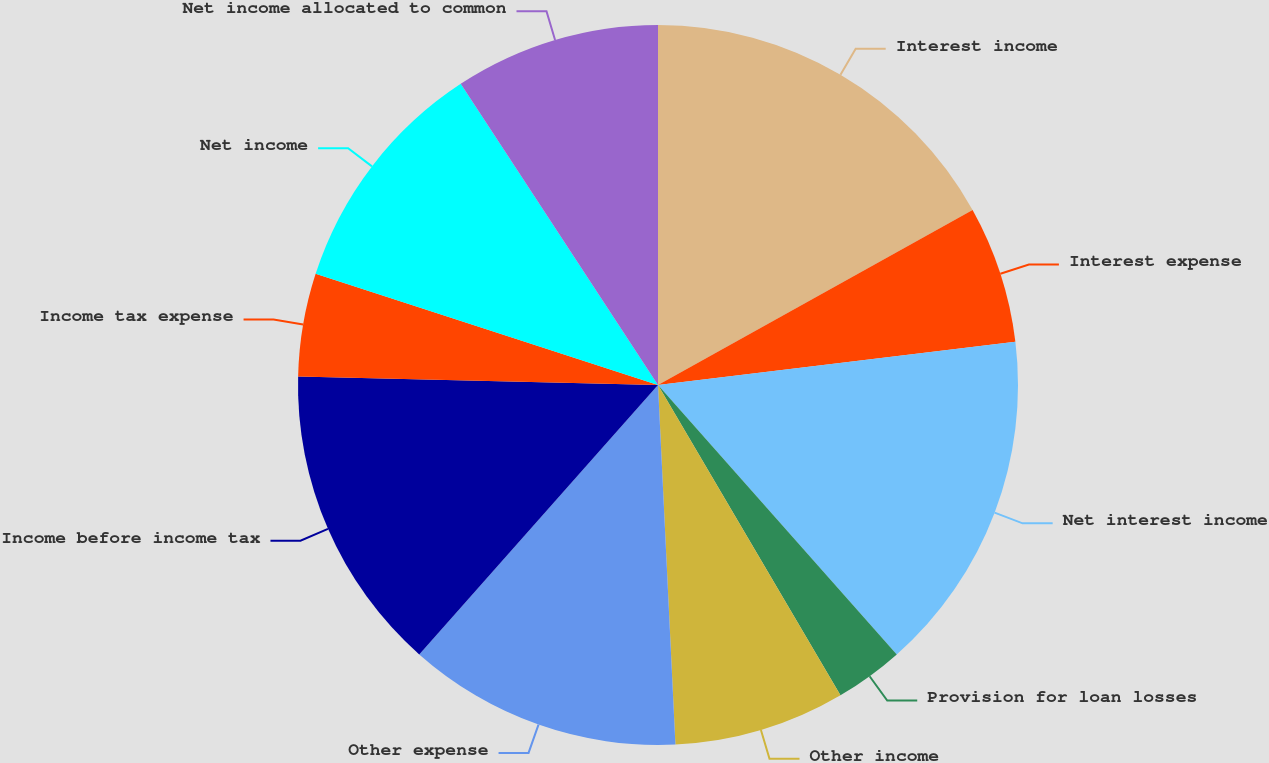<chart> <loc_0><loc_0><loc_500><loc_500><pie_chart><fcel>Interest income<fcel>Interest expense<fcel>Net interest income<fcel>Provision for loan losses<fcel>Other income<fcel>Other expense<fcel>Income before income tax<fcel>Income tax expense<fcel>Net income<fcel>Net income allocated to common<nl><fcel>16.92%<fcel>6.16%<fcel>15.38%<fcel>3.08%<fcel>7.69%<fcel>12.31%<fcel>13.84%<fcel>4.62%<fcel>10.77%<fcel>9.23%<nl></chart> 